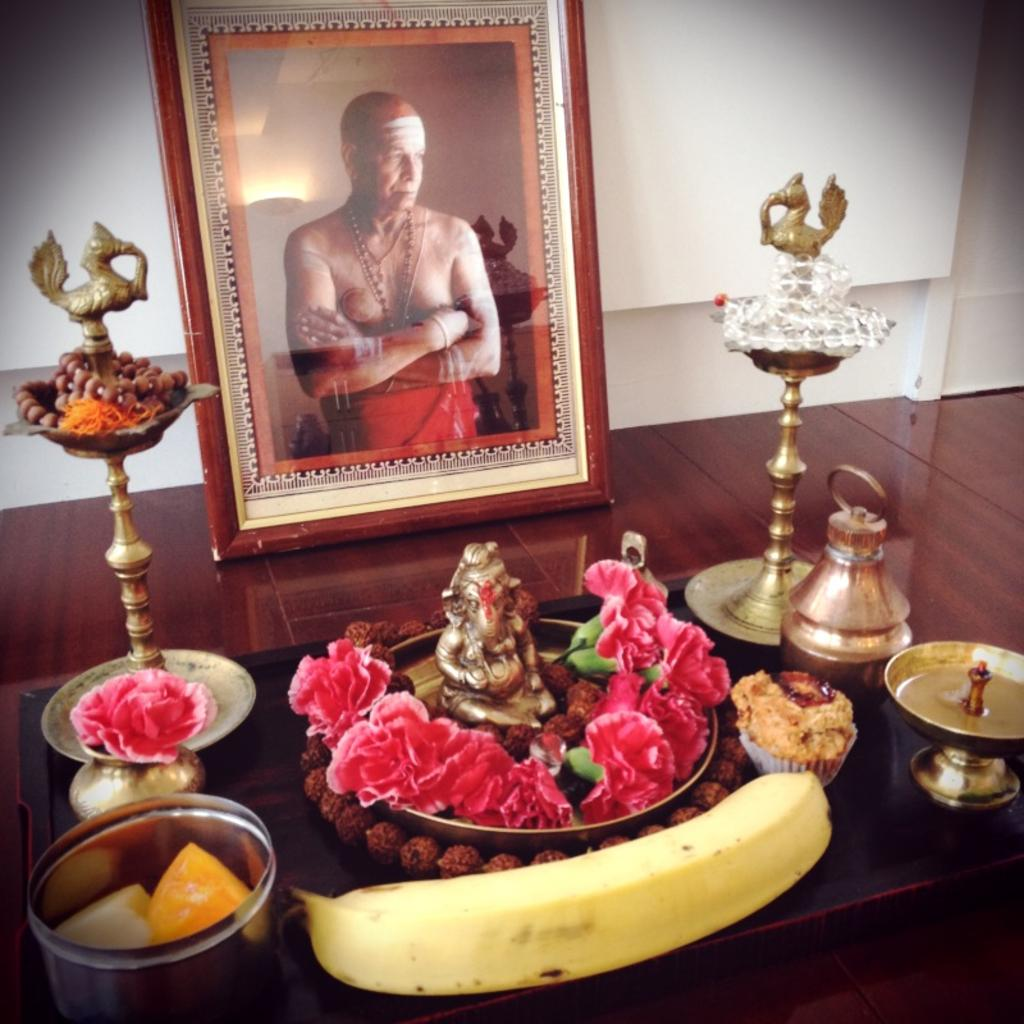What object is present in the image that typically holds a picture? There is a photo frame in the image. Who is depicted in the picture inside the photo frame? The photo frame contains a picture of a man. What items are placed at the bottom of the photo frame? There is a banana and flowers at the bottom of the photo frame. What religious or spiritual object can be seen in the image? There is an idol in the image. What object is located on the left side of the image? There is a box on the left side of the image. What type of line can be seen connecting the banana and the flowers in the image? There is no line connecting the banana and the flowers in the image; they are simply placed next to each other. 